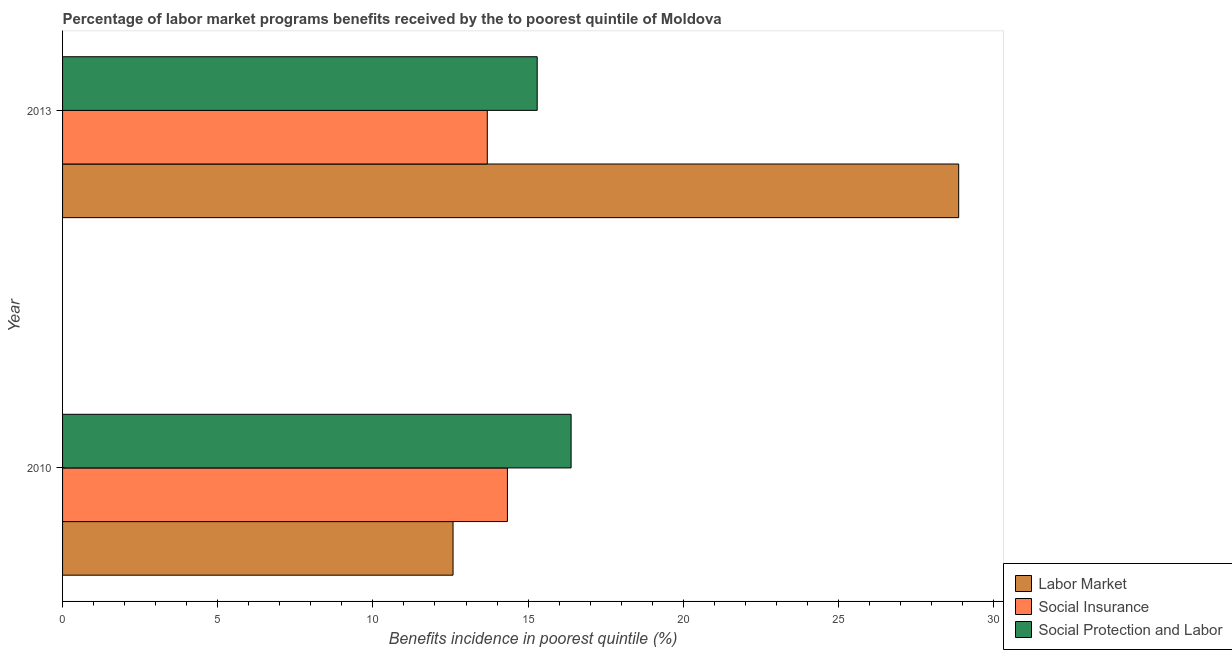How many groups of bars are there?
Your answer should be very brief. 2. Are the number of bars per tick equal to the number of legend labels?
Keep it short and to the point. Yes. How many bars are there on the 1st tick from the top?
Your answer should be compact. 3. How many bars are there on the 2nd tick from the bottom?
Give a very brief answer. 3. What is the label of the 2nd group of bars from the top?
Keep it short and to the point. 2010. In how many cases, is the number of bars for a given year not equal to the number of legend labels?
Provide a short and direct response. 0. What is the percentage of benefits received due to social insurance programs in 2010?
Offer a very short reply. 14.33. Across all years, what is the maximum percentage of benefits received due to labor market programs?
Your answer should be very brief. 28.88. Across all years, what is the minimum percentage of benefits received due to labor market programs?
Your answer should be very brief. 12.58. In which year was the percentage of benefits received due to labor market programs maximum?
Provide a short and direct response. 2013. What is the total percentage of benefits received due to labor market programs in the graph?
Ensure brevity in your answer.  41.46. What is the difference between the percentage of benefits received due to social protection programs in 2010 and that in 2013?
Ensure brevity in your answer.  1.09. What is the difference between the percentage of benefits received due to social insurance programs in 2010 and the percentage of benefits received due to labor market programs in 2013?
Offer a terse response. -14.54. What is the average percentage of benefits received due to social protection programs per year?
Ensure brevity in your answer.  15.84. In the year 2010, what is the difference between the percentage of benefits received due to social protection programs and percentage of benefits received due to social insurance programs?
Keep it short and to the point. 2.05. What is the ratio of the percentage of benefits received due to social protection programs in 2010 to that in 2013?
Provide a short and direct response. 1.07. Is the percentage of benefits received due to social protection programs in 2010 less than that in 2013?
Give a very brief answer. No. In how many years, is the percentage of benefits received due to social insurance programs greater than the average percentage of benefits received due to social insurance programs taken over all years?
Your answer should be very brief. 1. What does the 1st bar from the top in 2013 represents?
Provide a short and direct response. Social Protection and Labor. What does the 3rd bar from the bottom in 2013 represents?
Keep it short and to the point. Social Protection and Labor. Does the graph contain grids?
Your answer should be very brief. No. Where does the legend appear in the graph?
Make the answer very short. Bottom right. How many legend labels are there?
Your answer should be very brief. 3. What is the title of the graph?
Keep it short and to the point. Percentage of labor market programs benefits received by the to poorest quintile of Moldova. What is the label or title of the X-axis?
Offer a very short reply. Benefits incidence in poorest quintile (%). What is the Benefits incidence in poorest quintile (%) of Labor Market in 2010?
Ensure brevity in your answer.  12.58. What is the Benefits incidence in poorest quintile (%) of Social Insurance in 2010?
Provide a succinct answer. 14.33. What is the Benefits incidence in poorest quintile (%) in Social Protection and Labor in 2010?
Your response must be concise. 16.39. What is the Benefits incidence in poorest quintile (%) in Labor Market in 2013?
Offer a very short reply. 28.88. What is the Benefits incidence in poorest quintile (%) in Social Insurance in 2013?
Make the answer very short. 13.69. What is the Benefits incidence in poorest quintile (%) in Social Protection and Labor in 2013?
Provide a short and direct response. 15.29. Across all years, what is the maximum Benefits incidence in poorest quintile (%) of Labor Market?
Your answer should be very brief. 28.88. Across all years, what is the maximum Benefits incidence in poorest quintile (%) of Social Insurance?
Your response must be concise. 14.33. Across all years, what is the maximum Benefits incidence in poorest quintile (%) in Social Protection and Labor?
Offer a terse response. 16.39. Across all years, what is the minimum Benefits incidence in poorest quintile (%) of Labor Market?
Your answer should be very brief. 12.58. Across all years, what is the minimum Benefits incidence in poorest quintile (%) of Social Insurance?
Offer a terse response. 13.69. Across all years, what is the minimum Benefits incidence in poorest quintile (%) in Social Protection and Labor?
Make the answer very short. 15.29. What is the total Benefits incidence in poorest quintile (%) in Labor Market in the graph?
Keep it short and to the point. 41.46. What is the total Benefits incidence in poorest quintile (%) in Social Insurance in the graph?
Provide a succinct answer. 28.02. What is the total Benefits incidence in poorest quintile (%) of Social Protection and Labor in the graph?
Ensure brevity in your answer.  31.68. What is the difference between the Benefits incidence in poorest quintile (%) of Labor Market in 2010 and that in 2013?
Offer a very short reply. -16.29. What is the difference between the Benefits incidence in poorest quintile (%) of Social Insurance in 2010 and that in 2013?
Provide a succinct answer. 0.65. What is the difference between the Benefits incidence in poorest quintile (%) of Social Protection and Labor in 2010 and that in 2013?
Provide a short and direct response. 1.09. What is the difference between the Benefits incidence in poorest quintile (%) in Labor Market in 2010 and the Benefits incidence in poorest quintile (%) in Social Insurance in 2013?
Ensure brevity in your answer.  -1.1. What is the difference between the Benefits incidence in poorest quintile (%) of Labor Market in 2010 and the Benefits incidence in poorest quintile (%) of Social Protection and Labor in 2013?
Your answer should be very brief. -2.71. What is the difference between the Benefits incidence in poorest quintile (%) in Social Insurance in 2010 and the Benefits incidence in poorest quintile (%) in Social Protection and Labor in 2013?
Offer a terse response. -0.96. What is the average Benefits incidence in poorest quintile (%) of Labor Market per year?
Provide a succinct answer. 20.73. What is the average Benefits incidence in poorest quintile (%) of Social Insurance per year?
Your answer should be very brief. 14.01. What is the average Benefits incidence in poorest quintile (%) in Social Protection and Labor per year?
Offer a terse response. 15.84. In the year 2010, what is the difference between the Benefits incidence in poorest quintile (%) in Labor Market and Benefits incidence in poorest quintile (%) in Social Insurance?
Your response must be concise. -1.75. In the year 2010, what is the difference between the Benefits incidence in poorest quintile (%) of Labor Market and Benefits incidence in poorest quintile (%) of Social Protection and Labor?
Ensure brevity in your answer.  -3.8. In the year 2010, what is the difference between the Benefits incidence in poorest quintile (%) in Social Insurance and Benefits incidence in poorest quintile (%) in Social Protection and Labor?
Your answer should be very brief. -2.05. In the year 2013, what is the difference between the Benefits incidence in poorest quintile (%) of Labor Market and Benefits incidence in poorest quintile (%) of Social Insurance?
Your answer should be very brief. 15.19. In the year 2013, what is the difference between the Benefits incidence in poorest quintile (%) in Labor Market and Benefits incidence in poorest quintile (%) in Social Protection and Labor?
Your answer should be very brief. 13.58. In the year 2013, what is the difference between the Benefits incidence in poorest quintile (%) in Social Insurance and Benefits incidence in poorest quintile (%) in Social Protection and Labor?
Ensure brevity in your answer.  -1.61. What is the ratio of the Benefits incidence in poorest quintile (%) in Labor Market in 2010 to that in 2013?
Offer a very short reply. 0.44. What is the ratio of the Benefits incidence in poorest quintile (%) in Social Insurance in 2010 to that in 2013?
Your answer should be compact. 1.05. What is the ratio of the Benefits incidence in poorest quintile (%) of Social Protection and Labor in 2010 to that in 2013?
Give a very brief answer. 1.07. What is the difference between the highest and the second highest Benefits incidence in poorest quintile (%) in Labor Market?
Offer a terse response. 16.29. What is the difference between the highest and the second highest Benefits incidence in poorest quintile (%) of Social Insurance?
Offer a terse response. 0.65. What is the difference between the highest and the second highest Benefits incidence in poorest quintile (%) of Social Protection and Labor?
Offer a terse response. 1.09. What is the difference between the highest and the lowest Benefits incidence in poorest quintile (%) in Labor Market?
Keep it short and to the point. 16.29. What is the difference between the highest and the lowest Benefits incidence in poorest quintile (%) in Social Insurance?
Give a very brief answer. 0.65. What is the difference between the highest and the lowest Benefits incidence in poorest quintile (%) of Social Protection and Labor?
Keep it short and to the point. 1.09. 